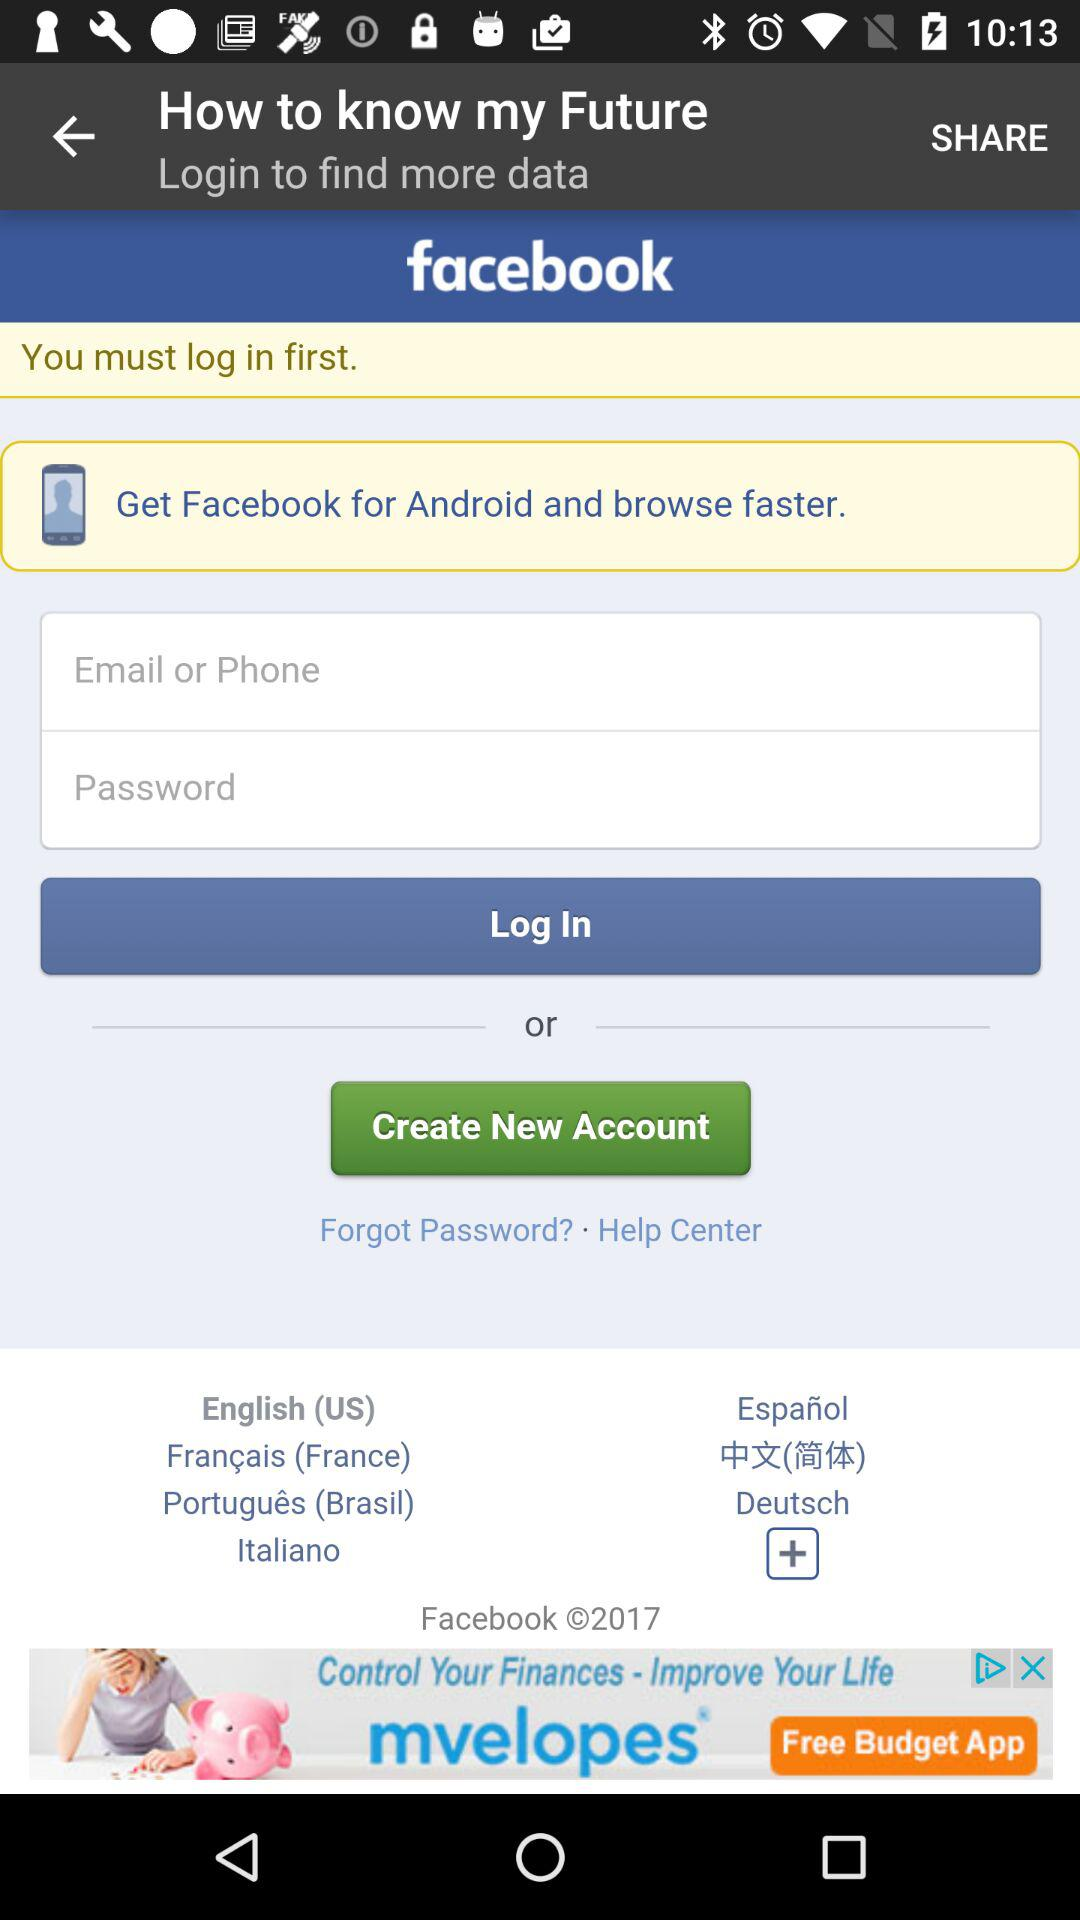Which language is selected? The selected language is English (US). 